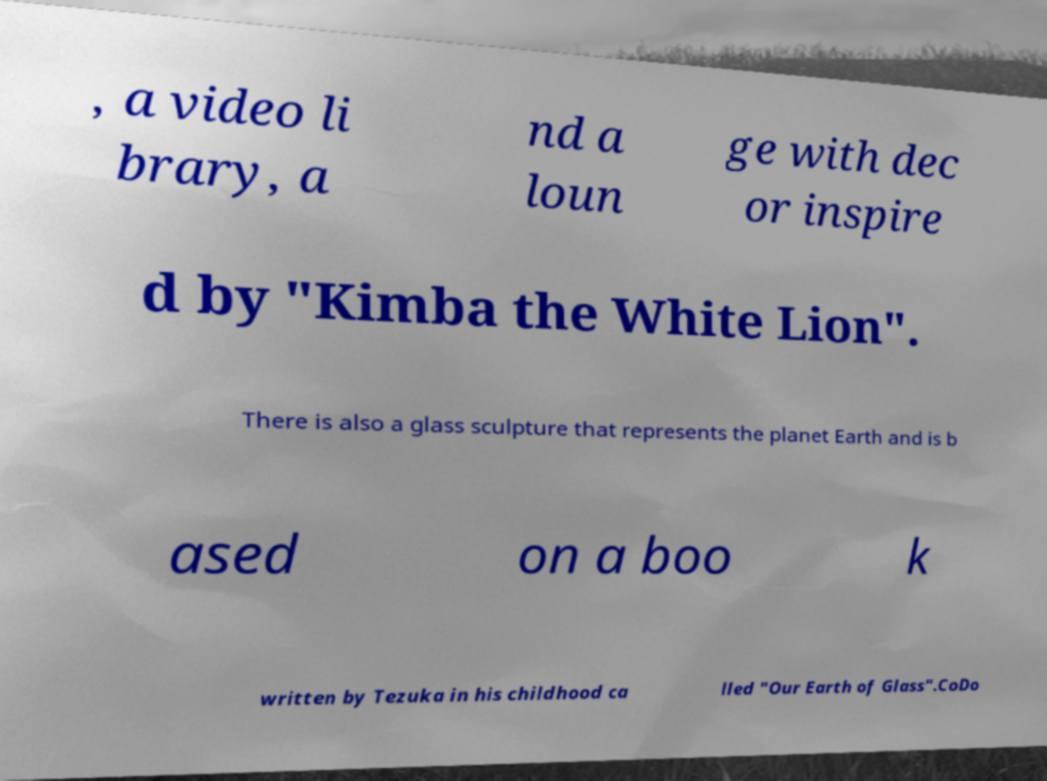Please identify and transcribe the text found in this image. , a video li brary, a nd a loun ge with dec or inspire d by "Kimba the White Lion". There is also a glass sculpture that represents the planet Earth and is b ased on a boo k written by Tezuka in his childhood ca lled "Our Earth of Glass".CoDo 